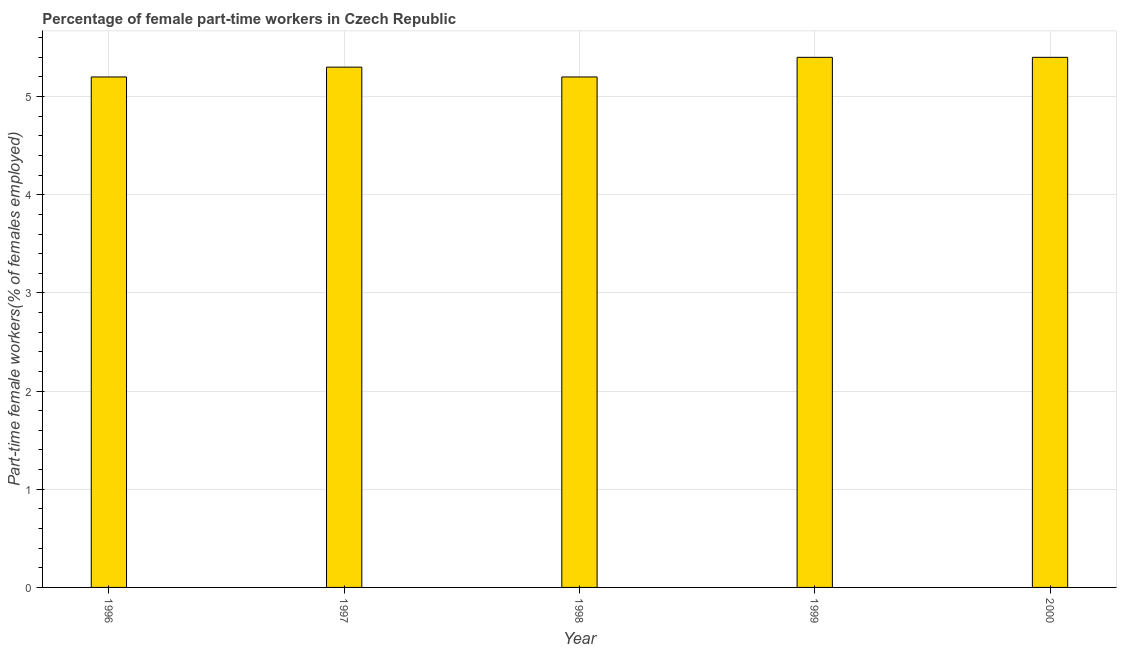Does the graph contain any zero values?
Your answer should be very brief. No. Does the graph contain grids?
Offer a very short reply. Yes. What is the title of the graph?
Provide a succinct answer. Percentage of female part-time workers in Czech Republic. What is the label or title of the Y-axis?
Your answer should be compact. Part-time female workers(% of females employed). What is the percentage of part-time female workers in 1998?
Make the answer very short. 5.2. Across all years, what is the maximum percentage of part-time female workers?
Provide a succinct answer. 5.4. Across all years, what is the minimum percentage of part-time female workers?
Your answer should be very brief. 5.2. In which year was the percentage of part-time female workers maximum?
Offer a terse response. 1999. In which year was the percentage of part-time female workers minimum?
Ensure brevity in your answer.  1996. What is the sum of the percentage of part-time female workers?
Ensure brevity in your answer.  26.5. What is the difference between the percentage of part-time female workers in 1996 and 1998?
Ensure brevity in your answer.  0. What is the median percentage of part-time female workers?
Provide a succinct answer. 5.3. What is the ratio of the percentage of part-time female workers in 1996 to that in 1998?
Make the answer very short. 1. Is the percentage of part-time female workers in 1996 less than that in 1998?
Give a very brief answer. No. Is the difference between the percentage of part-time female workers in 1996 and 2000 greater than the difference between any two years?
Your answer should be very brief. Yes. Is the sum of the percentage of part-time female workers in 1997 and 1999 greater than the maximum percentage of part-time female workers across all years?
Offer a terse response. Yes. In how many years, is the percentage of part-time female workers greater than the average percentage of part-time female workers taken over all years?
Ensure brevity in your answer.  3. Are all the bars in the graph horizontal?
Provide a succinct answer. No. How many years are there in the graph?
Make the answer very short. 5. What is the difference between two consecutive major ticks on the Y-axis?
Provide a short and direct response. 1. What is the Part-time female workers(% of females employed) of 1996?
Provide a succinct answer. 5.2. What is the Part-time female workers(% of females employed) of 1997?
Give a very brief answer. 5.3. What is the Part-time female workers(% of females employed) in 1998?
Provide a succinct answer. 5.2. What is the Part-time female workers(% of females employed) of 1999?
Keep it short and to the point. 5.4. What is the Part-time female workers(% of females employed) in 2000?
Provide a succinct answer. 5.4. What is the difference between the Part-time female workers(% of females employed) in 1996 and 1997?
Keep it short and to the point. -0.1. What is the difference between the Part-time female workers(% of females employed) in 1996 and 1998?
Give a very brief answer. 0. What is the difference between the Part-time female workers(% of females employed) in 1996 and 1999?
Your answer should be very brief. -0.2. What is the difference between the Part-time female workers(% of females employed) in 1996 and 2000?
Your answer should be compact. -0.2. What is the difference between the Part-time female workers(% of females employed) in 1997 and 1999?
Your answer should be compact. -0.1. What is the difference between the Part-time female workers(% of females employed) in 1998 and 1999?
Your response must be concise. -0.2. What is the difference between the Part-time female workers(% of females employed) in 1998 and 2000?
Provide a short and direct response. -0.2. What is the ratio of the Part-time female workers(% of females employed) in 1996 to that in 1997?
Your answer should be very brief. 0.98. What is the ratio of the Part-time female workers(% of females employed) in 1996 to that in 1998?
Offer a very short reply. 1. What is the ratio of the Part-time female workers(% of females employed) in 1996 to that in 2000?
Your answer should be compact. 0.96. What is the ratio of the Part-time female workers(% of females employed) in 1997 to that in 1998?
Offer a very short reply. 1.02. What is the ratio of the Part-time female workers(% of females employed) in 1997 to that in 2000?
Offer a terse response. 0.98. What is the ratio of the Part-time female workers(% of females employed) in 1998 to that in 2000?
Offer a terse response. 0.96. What is the ratio of the Part-time female workers(% of females employed) in 1999 to that in 2000?
Keep it short and to the point. 1. 